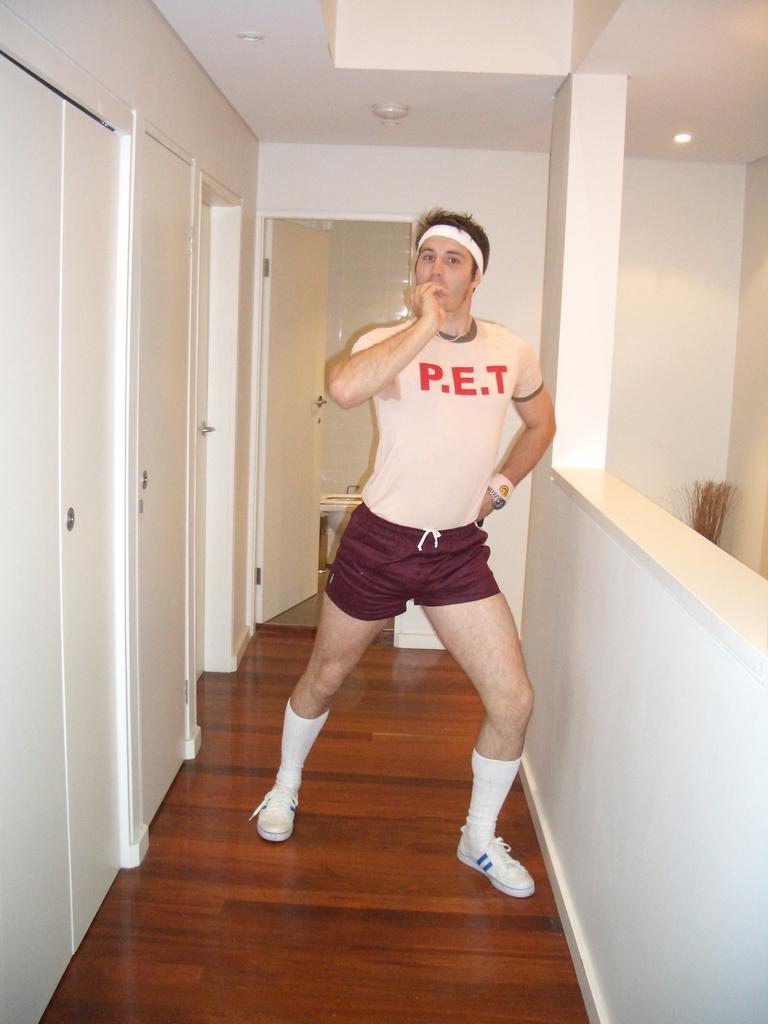<image>
Share a concise interpretation of the image provided. A man in shorts posing for a picture and on his Tee shirt it says P.E.T. 